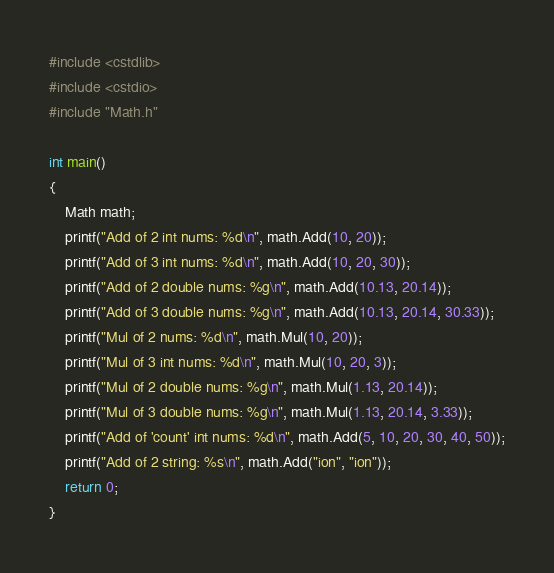Convert code to text. <code><loc_0><loc_0><loc_500><loc_500><_C++_>#include <cstdlib>
#include <cstdio>
#include "Math.h"

int main()
{
	Math math;
	printf("Add of 2 int nums: %d\n", math.Add(10, 20));
	printf("Add of 3 int nums: %d\n", math.Add(10, 20, 30));
	printf("Add of 2 double nums: %g\n", math.Add(10.13, 20.14));
	printf("Add of 3 double nums: %g\n", math.Add(10.13, 20.14, 30.33));
	printf("Mul of 2 nums: %d\n", math.Mul(10, 20));
	printf("Mul of 3 int nums: %d\n", math.Mul(10, 20, 3));
	printf("Mul of 2 double nums: %g\n", math.Mul(1.13, 20.14));
	printf("Mul of 3 double nums: %g\n", math.Mul(1.13, 20.14, 3.33));
	printf("Add of 'count' int nums: %d\n", math.Add(5, 10, 20, 30, 40, 50));
	printf("Add of 2 string: %s\n", math.Add("ion", "ion"));
	return 0;
}</code> 